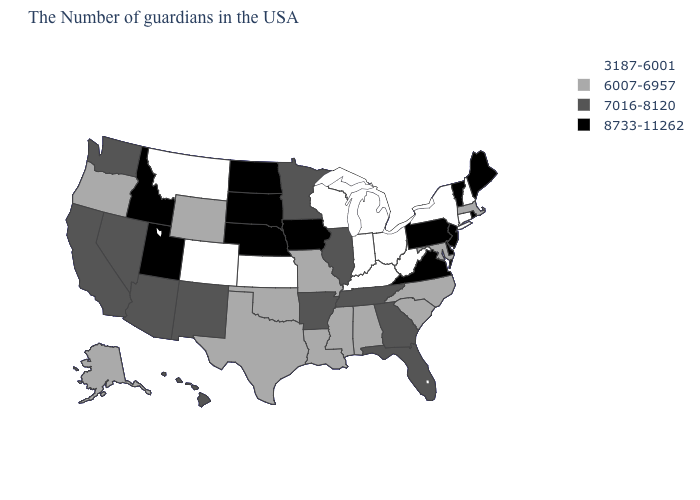Name the states that have a value in the range 8733-11262?
Write a very short answer. Maine, Rhode Island, Vermont, New Jersey, Delaware, Pennsylvania, Virginia, Iowa, Nebraska, South Dakota, North Dakota, Utah, Idaho. How many symbols are there in the legend?
Concise answer only. 4. What is the value of Alabama?
Concise answer only. 6007-6957. Name the states that have a value in the range 3187-6001?
Concise answer only. New Hampshire, Connecticut, New York, West Virginia, Ohio, Michigan, Kentucky, Indiana, Wisconsin, Kansas, Colorado, Montana. Does Kansas have the lowest value in the USA?
Be succinct. Yes. What is the highest value in the USA?
Give a very brief answer. 8733-11262. Does Idaho have a higher value than Vermont?
Be succinct. No. Name the states that have a value in the range 3187-6001?
Give a very brief answer. New Hampshire, Connecticut, New York, West Virginia, Ohio, Michigan, Kentucky, Indiana, Wisconsin, Kansas, Colorado, Montana. What is the highest value in the USA?
Concise answer only. 8733-11262. Among the states that border Delaware , does Maryland have the lowest value?
Concise answer only. Yes. Does West Virginia have a lower value than Indiana?
Quick response, please. No. Does the first symbol in the legend represent the smallest category?
Write a very short answer. Yes. Name the states that have a value in the range 7016-8120?
Concise answer only. Florida, Georgia, Tennessee, Illinois, Arkansas, Minnesota, New Mexico, Arizona, Nevada, California, Washington, Hawaii. Which states hav the highest value in the MidWest?
Keep it brief. Iowa, Nebraska, South Dakota, North Dakota. What is the lowest value in the West?
Write a very short answer. 3187-6001. 